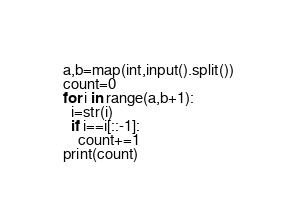Convert code to text. <code><loc_0><loc_0><loc_500><loc_500><_Python_>a,b=map(int,input().split())
count=0
for i in range(a,b+1):
  i=str(i)
  if i==i[::-1]:
    count+=1
print(count)
</code> 